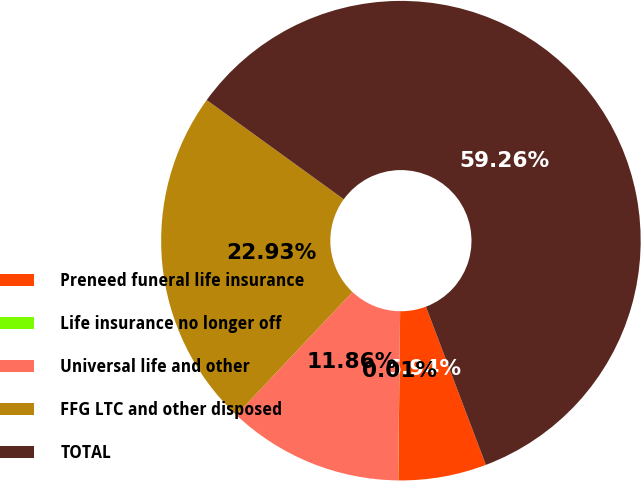<chart> <loc_0><loc_0><loc_500><loc_500><pie_chart><fcel>Preneed funeral life insurance<fcel>Life insurance no longer off<fcel>Universal life and other<fcel>FFG LTC and other disposed<fcel>TOTAL<nl><fcel>5.94%<fcel>0.01%<fcel>11.86%<fcel>22.93%<fcel>59.26%<nl></chart> 